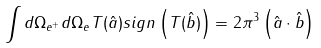<formula> <loc_0><loc_0><loc_500><loc_500>\int d \Omega _ { e ^ { + } } d \Omega _ { e } T ( \hat { a } ) s i g n \left ( T ( \hat { b } ) \right ) = 2 \pi ^ { 3 } \left ( \hat { a } \cdot \hat { b } \right )</formula> 